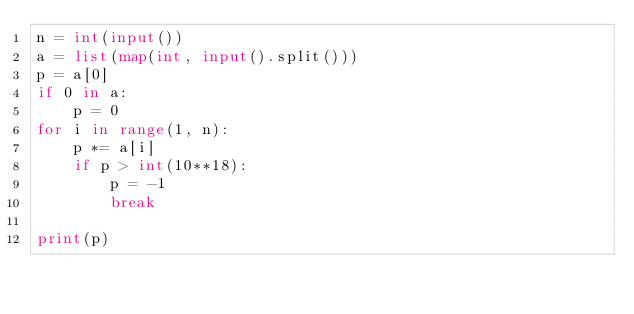Convert code to text. <code><loc_0><loc_0><loc_500><loc_500><_Python_>n = int(input())
a = list(map(int, input().split()))
p = a[0]
if 0 in a:
    p = 0
for i in range(1, n):
    p *= a[i]
    if p > int(10**18):
        p = -1
        break

print(p)
</code> 